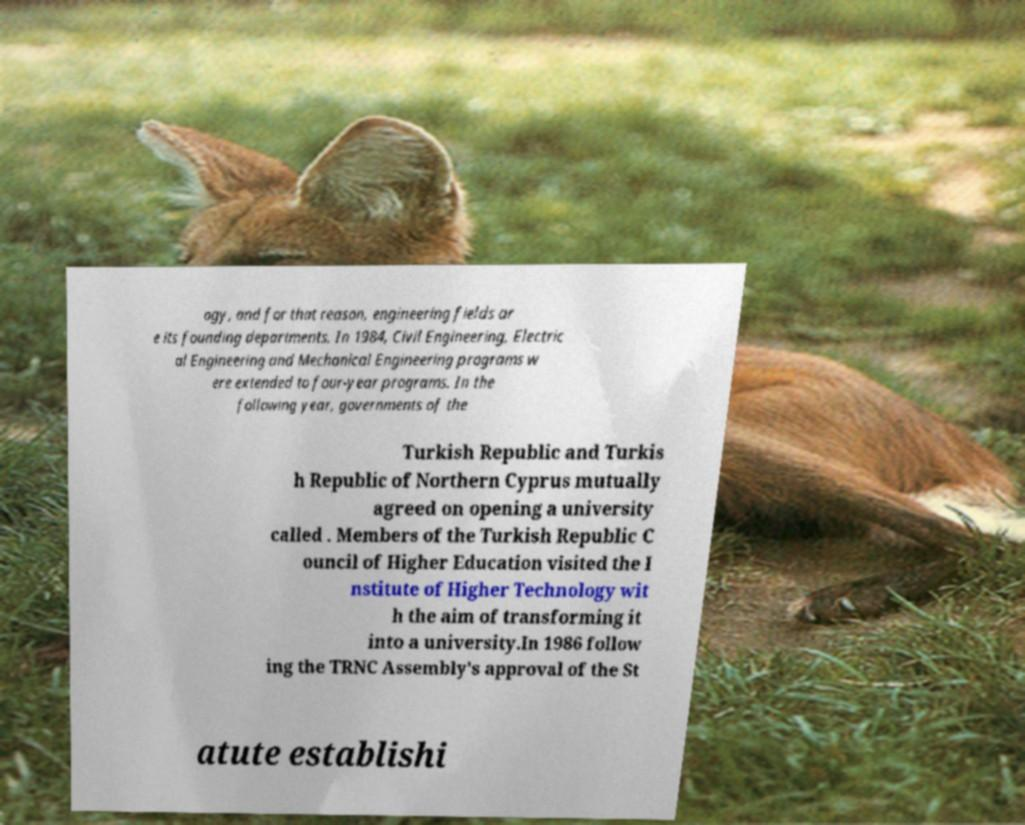There's text embedded in this image that I need extracted. Can you transcribe it verbatim? ogy, and for that reason, engineering fields ar e its founding departments. In 1984, Civil Engineering, Electric al Engineering and Mechanical Engineering programs w ere extended to four-year programs. In the following year, governments of the Turkish Republic and Turkis h Republic of Northern Cyprus mutually agreed on opening a university called . Members of the Turkish Republic C ouncil of Higher Education visited the I nstitute of Higher Technology wit h the aim of transforming it into a university.In 1986 follow ing the TRNC Assembly's approval of the St atute establishi 